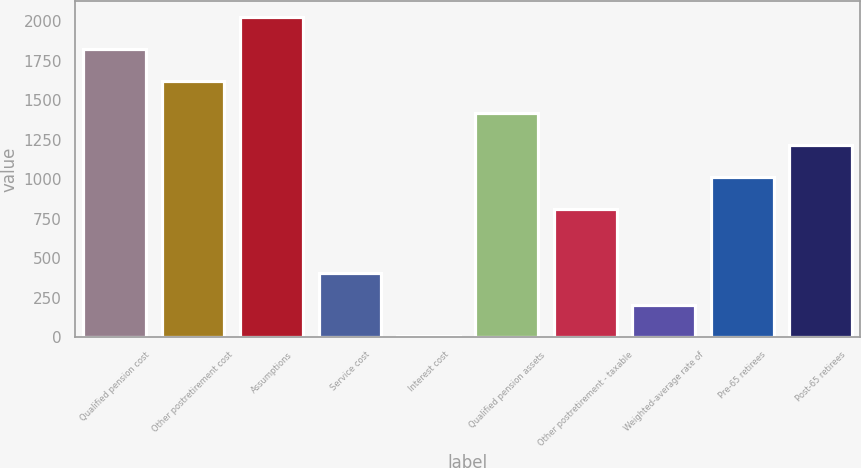Convert chart to OTSL. <chart><loc_0><loc_0><loc_500><loc_500><bar_chart><fcel>Qualified pension cost<fcel>Other postretirement cost<fcel>Assumptions<fcel>Service cost<fcel>Interest cost<fcel>Qualified pension assets<fcel>Other postretirement - taxable<fcel>Weighted-average rate of<fcel>Pre-65 retirees<fcel>Post-65 retirees<nl><fcel>1823.8<fcel>1621.57<fcel>2026.03<fcel>408.19<fcel>3.73<fcel>1419.34<fcel>812.65<fcel>205.96<fcel>1014.88<fcel>1217.11<nl></chart> 